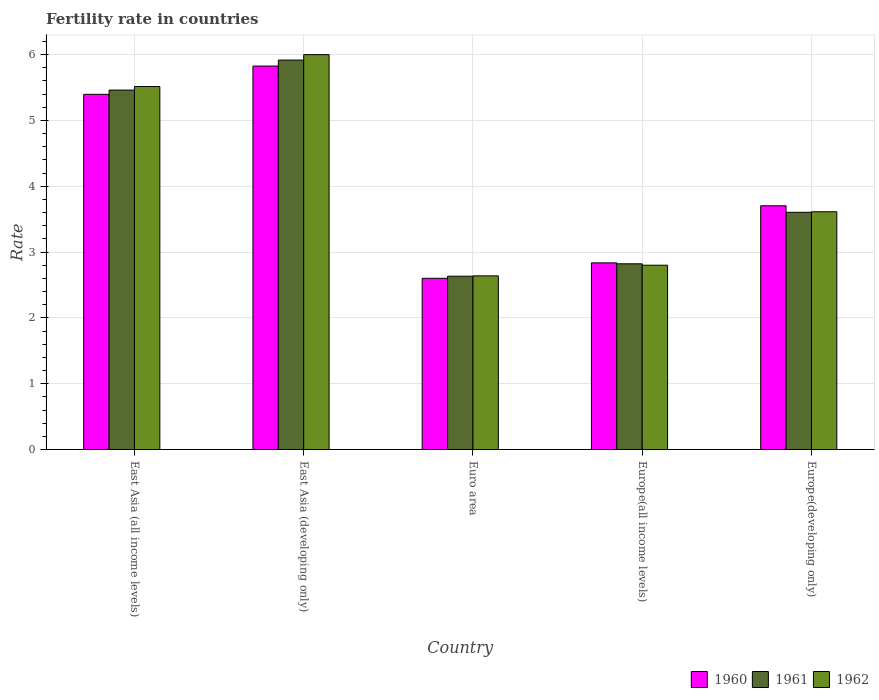How many groups of bars are there?
Keep it short and to the point. 5. Are the number of bars per tick equal to the number of legend labels?
Your answer should be compact. Yes. What is the label of the 4th group of bars from the left?
Your response must be concise. Europe(all income levels). What is the fertility rate in 1961 in Euro area?
Keep it short and to the point. 2.63. Across all countries, what is the maximum fertility rate in 1961?
Give a very brief answer. 5.92. Across all countries, what is the minimum fertility rate in 1961?
Provide a succinct answer. 2.63. In which country was the fertility rate in 1962 maximum?
Offer a terse response. East Asia (developing only). What is the total fertility rate in 1962 in the graph?
Your answer should be compact. 20.57. What is the difference between the fertility rate in 1960 in East Asia (all income levels) and that in Europe(all income levels)?
Ensure brevity in your answer.  2.56. What is the difference between the fertility rate in 1960 in East Asia (all income levels) and the fertility rate in 1962 in East Asia (developing only)?
Offer a terse response. -0.6. What is the average fertility rate in 1961 per country?
Your answer should be compact. 4.09. What is the difference between the fertility rate of/in 1961 and fertility rate of/in 1962 in Europe(all income levels)?
Ensure brevity in your answer.  0.02. In how many countries, is the fertility rate in 1961 greater than 6?
Your answer should be compact. 0. What is the ratio of the fertility rate in 1961 in Euro area to that in Europe(developing only)?
Offer a very short reply. 0.73. Is the difference between the fertility rate in 1961 in Euro area and Europe(developing only) greater than the difference between the fertility rate in 1962 in Euro area and Europe(developing only)?
Provide a succinct answer. Yes. What is the difference between the highest and the second highest fertility rate in 1961?
Your answer should be very brief. 1.86. What is the difference between the highest and the lowest fertility rate in 1960?
Your response must be concise. 3.23. In how many countries, is the fertility rate in 1962 greater than the average fertility rate in 1962 taken over all countries?
Provide a succinct answer. 2. Is the sum of the fertility rate in 1961 in East Asia (developing only) and Euro area greater than the maximum fertility rate in 1960 across all countries?
Offer a very short reply. Yes. What does the 3rd bar from the right in East Asia (developing only) represents?
Provide a succinct answer. 1960. Is it the case that in every country, the sum of the fertility rate in 1960 and fertility rate in 1961 is greater than the fertility rate in 1962?
Give a very brief answer. Yes. How many bars are there?
Give a very brief answer. 15. Are the values on the major ticks of Y-axis written in scientific E-notation?
Provide a succinct answer. No. Where does the legend appear in the graph?
Provide a succinct answer. Bottom right. What is the title of the graph?
Ensure brevity in your answer.  Fertility rate in countries. What is the label or title of the X-axis?
Your answer should be compact. Country. What is the label or title of the Y-axis?
Give a very brief answer. Rate. What is the Rate in 1960 in East Asia (all income levels)?
Your answer should be compact. 5.4. What is the Rate of 1961 in East Asia (all income levels)?
Your response must be concise. 5.46. What is the Rate of 1962 in East Asia (all income levels)?
Make the answer very short. 5.52. What is the Rate in 1960 in East Asia (developing only)?
Provide a succinct answer. 5.83. What is the Rate in 1961 in East Asia (developing only)?
Offer a very short reply. 5.92. What is the Rate in 1962 in East Asia (developing only)?
Make the answer very short. 6. What is the Rate of 1960 in Euro area?
Provide a short and direct response. 2.6. What is the Rate of 1961 in Euro area?
Ensure brevity in your answer.  2.63. What is the Rate in 1962 in Euro area?
Provide a succinct answer. 2.64. What is the Rate of 1960 in Europe(all income levels)?
Ensure brevity in your answer.  2.84. What is the Rate of 1961 in Europe(all income levels)?
Your answer should be compact. 2.82. What is the Rate in 1962 in Europe(all income levels)?
Your answer should be compact. 2.8. What is the Rate in 1960 in Europe(developing only)?
Give a very brief answer. 3.7. What is the Rate of 1961 in Europe(developing only)?
Your answer should be compact. 3.6. What is the Rate of 1962 in Europe(developing only)?
Ensure brevity in your answer.  3.61. Across all countries, what is the maximum Rate in 1960?
Ensure brevity in your answer.  5.83. Across all countries, what is the maximum Rate of 1961?
Provide a short and direct response. 5.92. Across all countries, what is the maximum Rate of 1962?
Provide a short and direct response. 6. Across all countries, what is the minimum Rate in 1960?
Offer a very short reply. 2.6. Across all countries, what is the minimum Rate in 1961?
Offer a very short reply. 2.63. Across all countries, what is the minimum Rate of 1962?
Ensure brevity in your answer.  2.64. What is the total Rate of 1960 in the graph?
Offer a terse response. 20.36. What is the total Rate in 1961 in the graph?
Offer a terse response. 20.44. What is the total Rate of 1962 in the graph?
Offer a very short reply. 20.57. What is the difference between the Rate in 1960 in East Asia (all income levels) and that in East Asia (developing only)?
Your answer should be compact. -0.43. What is the difference between the Rate in 1961 in East Asia (all income levels) and that in East Asia (developing only)?
Provide a short and direct response. -0.46. What is the difference between the Rate of 1962 in East Asia (all income levels) and that in East Asia (developing only)?
Offer a terse response. -0.49. What is the difference between the Rate in 1960 in East Asia (all income levels) and that in Euro area?
Give a very brief answer. 2.8. What is the difference between the Rate of 1961 in East Asia (all income levels) and that in Euro area?
Your response must be concise. 2.83. What is the difference between the Rate in 1962 in East Asia (all income levels) and that in Euro area?
Your answer should be very brief. 2.88. What is the difference between the Rate of 1960 in East Asia (all income levels) and that in Europe(all income levels)?
Offer a terse response. 2.56. What is the difference between the Rate of 1961 in East Asia (all income levels) and that in Europe(all income levels)?
Your answer should be very brief. 2.64. What is the difference between the Rate of 1962 in East Asia (all income levels) and that in Europe(all income levels)?
Offer a very short reply. 2.71. What is the difference between the Rate of 1960 in East Asia (all income levels) and that in Europe(developing only)?
Provide a short and direct response. 1.69. What is the difference between the Rate in 1961 in East Asia (all income levels) and that in Europe(developing only)?
Ensure brevity in your answer.  1.86. What is the difference between the Rate of 1962 in East Asia (all income levels) and that in Europe(developing only)?
Give a very brief answer. 1.9. What is the difference between the Rate in 1960 in East Asia (developing only) and that in Euro area?
Give a very brief answer. 3.23. What is the difference between the Rate of 1961 in East Asia (developing only) and that in Euro area?
Your answer should be very brief. 3.28. What is the difference between the Rate of 1962 in East Asia (developing only) and that in Euro area?
Ensure brevity in your answer.  3.36. What is the difference between the Rate of 1960 in East Asia (developing only) and that in Europe(all income levels)?
Ensure brevity in your answer.  2.99. What is the difference between the Rate in 1961 in East Asia (developing only) and that in Europe(all income levels)?
Offer a terse response. 3.1. What is the difference between the Rate of 1962 in East Asia (developing only) and that in Europe(all income levels)?
Provide a short and direct response. 3.2. What is the difference between the Rate of 1960 in East Asia (developing only) and that in Europe(developing only)?
Provide a short and direct response. 2.12. What is the difference between the Rate in 1961 in East Asia (developing only) and that in Europe(developing only)?
Give a very brief answer. 2.31. What is the difference between the Rate of 1962 in East Asia (developing only) and that in Europe(developing only)?
Make the answer very short. 2.39. What is the difference between the Rate of 1960 in Euro area and that in Europe(all income levels)?
Ensure brevity in your answer.  -0.23. What is the difference between the Rate of 1961 in Euro area and that in Europe(all income levels)?
Provide a short and direct response. -0.19. What is the difference between the Rate in 1962 in Euro area and that in Europe(all income levels)?
Offer a terse response. -0.16. What is the difference between the Rate of 1960 in Euro area and that in Europe(developing only)?
Ensure brevity in your answer.  -1.1. What is the difference between the Rate of 1961 in Euro area and that in Europe(developing only)?
Your answer should be compact. -0.97. What is the difference between the Rate of 1962 in Euro area and that in Europe(developing only)?
Provide a succinct answer. -0.97. What is the difference between the Rate of 1960 in Europe(all income levels) and that in Europe(developing only)?
Keep it short and to the point. -0.87. What is the difference between the Rate of 1961 in Europe(all income levels) and that in Europe(developing only)?
Provide a short and direct response. -0.78. What is the difference between the Rate in 1962 in Europe(all income levels) and that in Europe(developing only)?
Keep it short and to the point. -0.81. What is the difference between the Rate in 1960 in East Asia (all income levels) and the Rate in 1961 in East Asia (developing only)?
Ensure brevity in your answer.  -0.52. What is the difference between the Rate of 1960 in East Asia (all income levels) and the Rate of 1962 in East Asia (developing only)?
Make the answer very short. -0.6. What is the difference between the Rate of 1961 in East Asia (all income levels) and the Rate of 1962 in East Asia (developing only)?
Offer a terse response. -0.54. What is the difference between the Rate of 1960 in East Asia (all income levels) and the Rate of 1961 in Euro area?
Ensure brevity in your answer.  2.76. What is the difference between the Rate of 1960 in East Asia (all income levels) and the Rate of 1962 in Euro area?
Give a very brief answer. 2.76. What is the difference between the Rate in 1961 in East Asia (all income levels) and the Rate in 1962 in Euro area?
Your answer should be compact. 2.82. What is the difference between the Rate in 1960 in East Asia (all income levels) and the Rate in 1961 in Europe(all income levels)?
Provide a succinct answer. 2.58. What is the difference between the Rate of 1960 in East Asia (all income levels) and the Rate of 1962 in Europe(all income levels)?
Your answer should be very brief. 2.6. What is the difference between the Rate in 1961 in East Asia (all income levels) and the Rate in 1962 in Europe(all income levels)?
Provide a short and direct response. 2.66. What is the difference between the Rate of 1960 in East Asia (all income levels) and the Rate of 1961 in Europe(developing only)?
Give a very brief answer. 1.79. What is the difference between the Rate of 1960 in East Asia (all income levels) and the Rate of 1962 in Europe(developing only)?
Provide a short and direct response. 1.78. What is the difference between the Rate of 1961 in East Asia (all income levels) and the Rate of 1962 in Europe(developing only)?
Keep it short and to the point. 1.85. What is the difference between the Rate in 1960 in East Asia (developing only) and the Rate in 1961 in Euro area?
Your answer should be compact. 3.19. What is the difference between the Rate of 1960 in East Asia (developing only) and the Rate of 1962 in Euro area?
Give a very brief answer. 3.19. What is the difference between the Rate of 1961 in East Asia (developing only) and the Rate of 1962 in Euro area?
Give a very brief answer. 3.28. What is the difference between the Rate in 1960 in East Asia (developing only) and the Rate in 1961 in Europe(all income levels)?
Your answer should be very brief. 3. What is the difference between the Rate in 1960 in East Asia (developing only) and the Rate in 1962 in Europe(all income levels)?
Offer a very short reply. 3.03. What is the difference between the Rate of 1961 in East Asia (developing only) and the Rate of 1962 in Europe(all income levels)?
Provide a succinct answer. 3.12. What is the difference between the Rate of 1960 in East Asia (developing only) and the Rate of 1961 in Europe(developing only)?
Provide a short and direct response. 2.22. What is the difference between the Rate of 1960 in East Asia (developing only) and the Rate of 1962 in Europe(developing only)?
Make the answer very short. 2.21. What is the difference between the Rate in 1961 in East Asia (developing only) and the Rate in 1962 in Europe(developing only)?
Your answer should be compact. 2.31. What is the difference between the Rate of 1960 in Euro area and the Rate of 1961 in Europe(all income levels)?
Your response must be concise. -0.22. What is the difference between the Rate of 1960 in Euro area and the Rate of 1962 in Europe(all income levels)?
Keep it short and to the point. -0.2. What is the difference between the Rate in 1961 in Euro area and the Rate in 1962 in Europe(all income levels)?
Offer a very short reply. -0.17. What is the difference between the Rate in 1960 in Euro area and the Rate in 1961 in Europe(developing only)?
Make the answer very short. -1. What is the difference between the Rate in 1960 in Euro area and the Rate in 1962 in Europe(developing only)?
Ensure brevity in your answer.  -1.01. What is the difference between the Rate in 1961 in Euro area and the Rate in 1962 in Europe(developing only)?
Keep it short and to the point. -0.98. What is the difference between the Rate in 1960 in Europe(all income levels) and the Rate in 1961 in Europe(developing only)?
Make the answer very short. -0.77. What is the difference between the Rate in 1960 in Europe(all income levels) and the Rate in 1962 in Europe(developing only)?
Offer a terse response. -0.78. What is the difference between the Rate in 1961 in Europe(all income levels) and the Rate in 1962 in Europe(developing only)?
Your response must be concise. -0.79. What is the average Rate in 1960 per country?
Offer a terse response. 4.07. What is the average Rate of 1961 per country?
Provide a short and direct response. 4.09. What is the average Rate of 1962 per country?
Provide a short and direct response. 4.11. What is the difference between the Rate of 1960 and Rate of 1961 in East Asia (all income levels)?
Your answer should be compact. -0.06. What is the difference between the Rate in 1960 and Rate in 1962 in East Asia (all income levels)?
Keep it short and to the point. -0.12. What is the difference between the Rate in 1961 and Rate in 1962 in East Asia (all income levels)?
Offer a very short reply. -0.05. What is the difference between the Rate of 1960 and Rate of 1961 in East Asia (developing only)?
Offer a terse response. -0.09. What is the difference between the Rate of 1960 and Rate of 1962 in East Asia (developing only)?
Your answer should be compact. -0.17. What is the difference between the Rate in 1961 and Rate in 1962 in East Asia (developing only)?
Provide a succinct answer. -0.08. What is the difference between the Rate of 1960 and Rate of 1961 in Euro area?
Your answer should be very brief. -0.03. What is the difference between the Rate of 1960 and Rate of 1962 in Euro area?
Keep it short and to the point. -0.04. What is the difference between the Rate in 1961 and Rate in 1962 in Euro area?
Ensure brevity in your answer.  -0.01. What is the difference between the Rate in 1960 and Rate in 1961 in Europe(all income levels)?
Keep it short and to the point. 0.01. What is the difference between the Rate of 1960 and Rate of 1962 in Europe(all income levels)?
Your response must be concise. 0.04. What is the difference between the Rate of 1961 and Rate of 1962 in Europe(all income levels)?
Your response must be concise. 0.02. What is the difference between the Rate in 1960 and Rate in 1961 in Europe(developing only)?
Make the answer very short. 0.1. What is the difference between the Rate of 1960 and Rate of 1962 in Europe(developing only)?
Make the answer very short. 0.09. What is the difference between the Rate of 1961 and Rate of 1962 in Europe(developing only)?
Your answer should be very brief. -0.01. What is the ratio of the Rate in 1960 in East Asia (all income levels) to that in East Asia (developing only)?
Offer a terse response. 0.93. What is the ratio of the Rate in 1961 in East Asia (all income levels) to that in East Asia (developing only)?
Make the answer very short. 0.92. What is the ratio of the Rate in 1962 in East Asia (all income levels) to that in East Asia (developing only)?
Your response must be concise. 0.92. What is the ratio of the Rate in 1960 in East Asia (all income levels) to that in Euro area?
Offer a very short reply. 2.07. What is the ratio of the Rate in 1961 in East Asia (all income levels) to that in Euro area?
Provide a short and direct response. 2.07. What is the ratio of the Rate of 1962 in East Asia (all income levels) to that in Euro area?
Your answer should be compact. 2.09. What is the ratio of the Rate of 1960 in East Asia (all income levels) to that in Europe(all income levels)?
Your answer should be very brief. 1.9. What is the ratio of the Rate in 1961 in East Asia (all income levels) to that in Europe(all income levels)?
Make the answer very short. 1.94. What is the ratio of the Rate in 1962 in East Asia (all income levels) to that in Europe(all income levels)?
Offer a terse response. 1.97. What is the ratio of the Rate in 1960 in East Asia (all income levels) to that in Europe(developing only)?
Provide a succinct answer. 1.46. What is the ratio of the Rate of 1961 in East Asia (all income levels) to that in Europe(developing only)?
Offer a very short reply. 1.52. What is the ratio of the Rate of 1962 in East Asia (all income levels) to that in Europe(developing only)?
Make the answer very short. 1.53. What is the ratio of the Rate in 1960 in East Asia (developing only) to that in Euro area?
Offer a very short reply. 2.24. What is the ratio of the Rate in 1961 in East Asia (developing only) to that in Euro area?
Offer a very short reply. 2.25. What is the ratio of the Rate in 1962 in East Asia (developing only) to that in Euro area?
Your answer should be very brief. 2.27. What is the ratio of the Rate in 1960 in East Asia (developing only) to that in Europe(all income levels)?
Your response must be concise. 2.05. What is the ratio of the Rate of 1961 in East Asia (developing only) to that in Europe(all income levels)?
Give a very brief answer. 2.1. What is the ratio of the Rate of 1962 in East Asia (developing only) to that in Europe(all income levels)?
Offer a very short reply. 2.14. What is the ratio of the Rate in 1960 in East Asia (developing only) to that in Europe(developing only)?
Offer a terse response. 1.57. What is the ratio of the Rate of 1961 in East Asia (developing only) to that in Europe(developing only)?
Your answer should be compact. 1.64. What is the ratio of the Rate of 1962 in East Asia (developing only) to that in Europe(developing only)?
Provide a succinct answer. 1.66. What is the ratio of the Rate in 1960 in Euro area to that in Europe(all income levels)?
Keep it short and to the point. 0.92. What is the ratio of the Rate of 1961 in Euro area to that in Europe(all income levels)?
Offer a terse response. 0.93. What is the ratio of the Rate in 1962 in Euro area to that in Europe(all income levels)?
Keep it short and to the point. 0.94. What is the ratio of the Rate in 1960 in Euro area to that in Europe(developing only)?
Your answer should be very brief. 0.7. What is the ratio of the Rate of 1961 in Euro area to that in Europe(developing only)?
Provide a short and direct response. 0.73. What is the ratio of the Rate of 1962 in Euro area to that in Europe(developing only)?
Offer a very short reply. 0.73. What is the ratio of the Rate in 1960 in Europe(all income levels) to that in Europe(developing only)?
Your response must be concise. 0.77. What is the ratio of the Rate in 1961 in Europe(all income levels) to that in Europe(developing only)?
Your answer should be compact. 0.78. What is the ratio of the Rate of 1962 in Europe(all income levels) to that in Europe(developing only)?
Provide a short and direct response. 0.78. What is the difference between the highest and the second highest Rate in 1960?
Ensure brevity in your answer.  0.43. What is the difference between the highest and the second highest Rate of 1961?
Your answer should be very brief. 0.46. What is the difference between the highest and the second highest Rate in 1962?
Provide a succinct answer. 0.49. What is the difference between the highest and the lowest Rate of 1960?
Give a very brief answer. 3.23. What is the difference between the highest and the lowest Rate in 1961?
Make the answer very short. 3.28. What is the difference between the highest and the lowest Rate of 1962?
Offer a terse response. 3.36. 